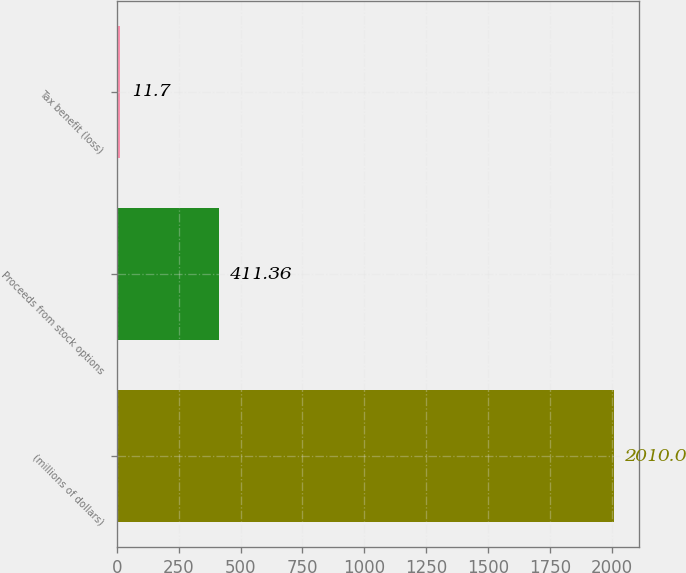Convert chart. <chart><loc_0><loc_0><loc_500><loc_500><bar_chart><fcel>(millions of dollars)<fcel>Proceeds from stock options<fcel>Tax benefit (loss)<nl><fcel>2010<fcel>411.36<fcel>11.7<nl></chart> 